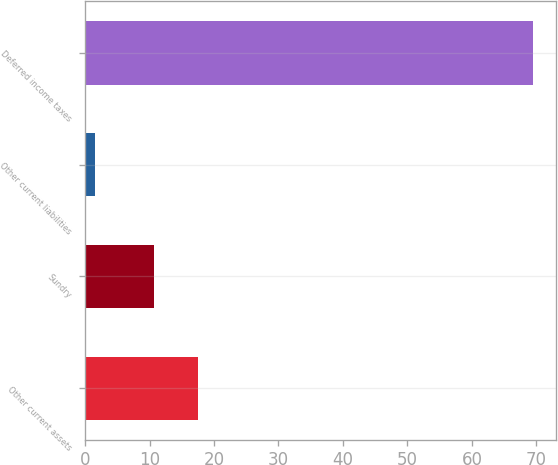Convert chart. <chart><loc_0><loc_0><loc_500><loc_500><bar_chart><fcel>Other current assets<fcel>Sundry<fcel>Other current liabilities<fcel>Deferred income taxes<nl><fcel>17.49<fcel>10.7<fcel>1.6<fcel>69.5<nl></chart> 